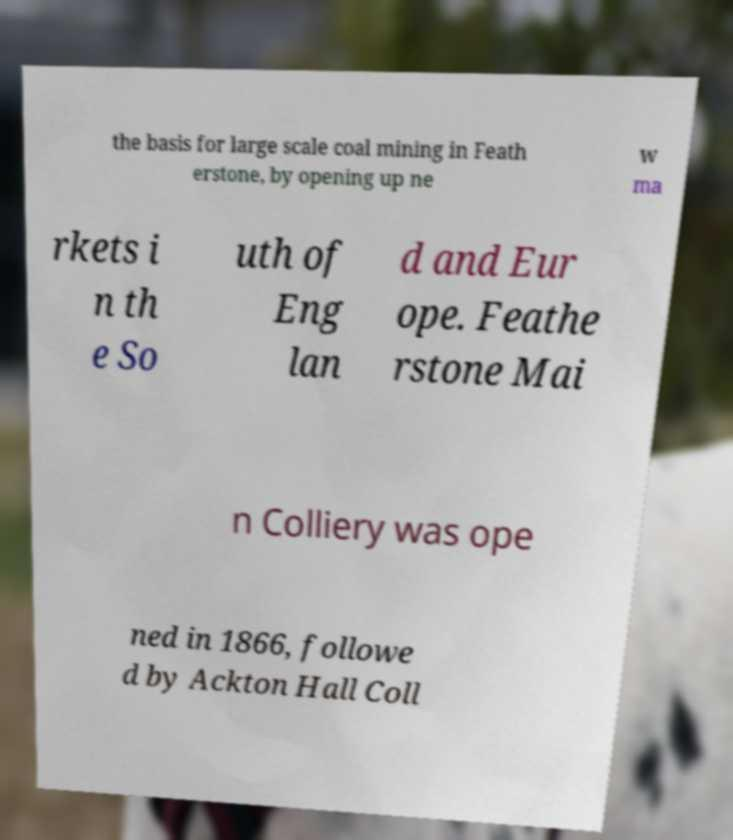Please read and relay the text visible in this image. What does it say? the basis for large scale coal mining in Feath erstone, by opening up ne w ma rkets i n th e So uth of Eng lan d and Eur ope. Feathe rstone Mai n Colliery was ope ned in 1866, followe d by Ackton Hall Coll 